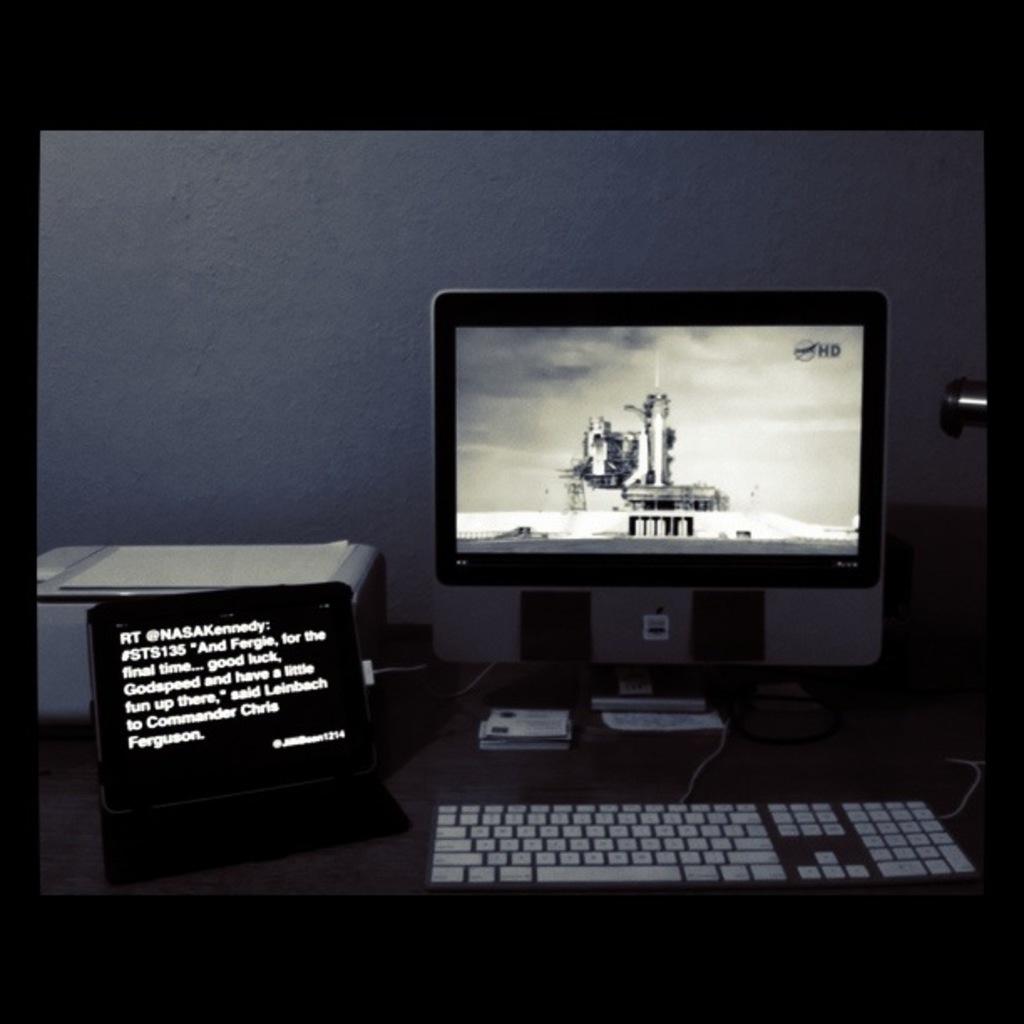Does the sign wish them good luck?/?
Ensure brevity in your answer.  Yes. 